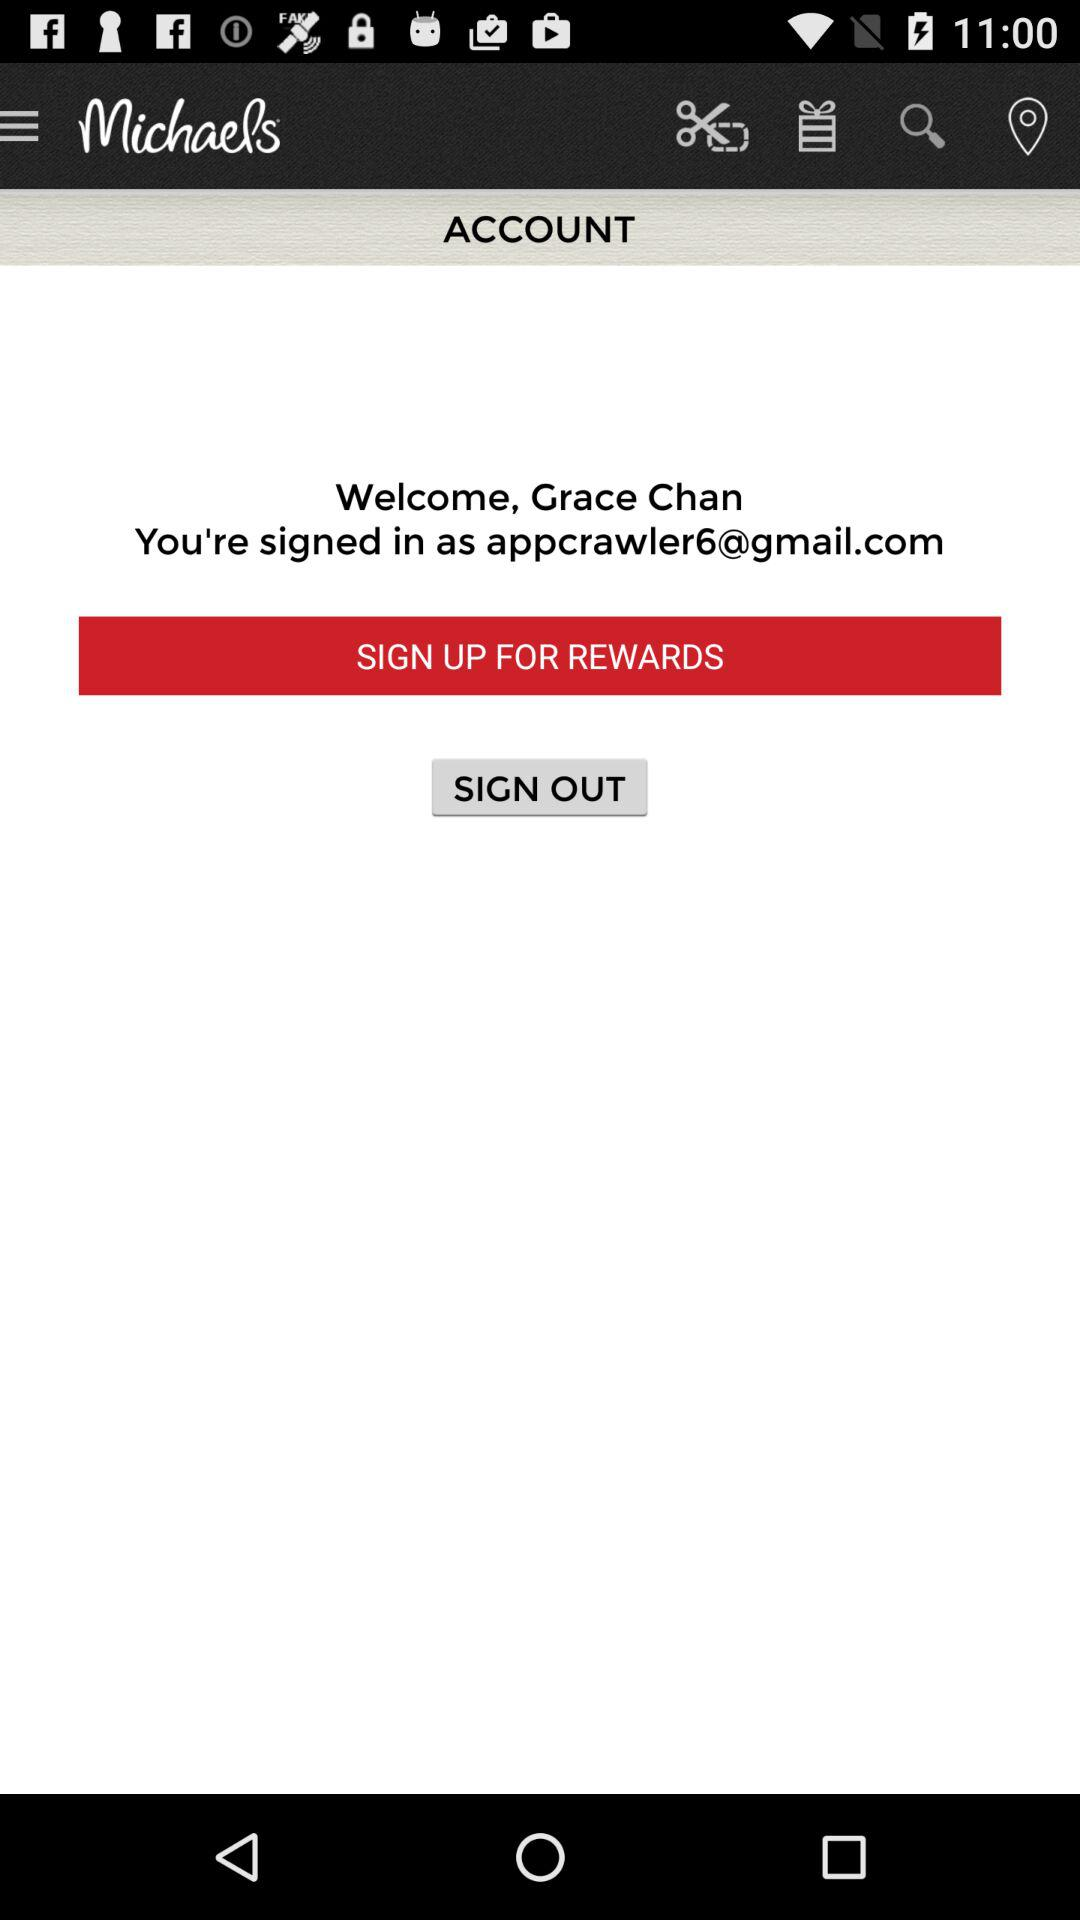What is the email address? The email address is appcrawler6@gmail.com. 